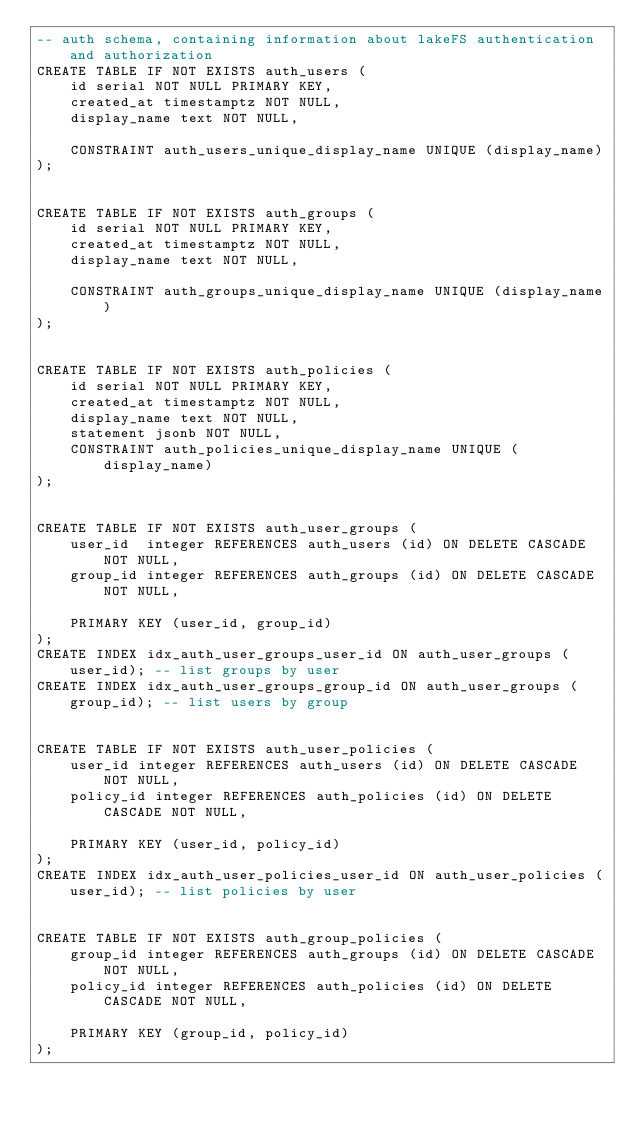Convert code to text. <code><loc_0><loc_0><loc_500><loc_500><_SQL_>-- auth schema, containing information about lakeFS authentication and authorization
CREATE TABLE IF NOT EXISTS auth_users (
    id serial NOT NULL PRIMARY KEY,
    created_at timestamptz NOT NULL,
    display_name text NOT NULL,

    CONSTRAINT auth_users_unique_display_name UNIQUE (display_name)
);


CREATE TABLE IF NOT EXISTS auth_groups (
    id serial NOT NULL PRIMARY KEY,
    created_at timestamptz NOT NULL,
    display_name text NOT NULL,

    CONSTRAINT auth_groups_unique_display_name UNIQUE (display_name)
);


CREATE TABLE IF NOT EXISTS auth_policies (
    id serial NOT NULL PRIMARY KEY,
    created_at timestamptz NOT NULL,
    display_name text NOT NULL,
    statement jsonb NOT NULL,
    CONSTRAINT auth_policies_unique_display_name UNIQUE (display_name)
);


CREATE TABLE IF NOT EXISTS auth_user_groups (
    user_id  integer REFERENCES auth_users (id) ON DELETE CASCADE NOT NULL,
    group_id integer REFERENCES auth_groups (id) ON DELETE CASCADE NOT NULL,

    PRIMARY KEY (user_id, group_id)
);
CREATE INDEX idx_auth_user_groups_user_id ON auth_user_groups (user_id); -- list groups by user
CREATE INDEX idx_auth_user_groups_group_id ON auth_user_groups (group_id); -- list users by group


CREATE TABLE IF NOT EXISTS auth_user_policies (
    user_id integer REFERENCES auth_users (id) ON DELETE CASCADE NOT NULL,
    policy_id integer REFERENCES auth_policies (id) ON DELETE CASCADE NOT NULL,

    PRIMARY KEY (user_id, policy_id)
);
CREATE INDEX idx_auth_user_policies_user_id ON auth_user_policies (user_id); -- list policies by user


CREATE TABLE IF NOT EXISTS auth_group_policies (
    group_id integer REFERENCES auth_groups (id) ON DELETE CASCADE NOT NULL,
    policy_id integer REFERENCES auth_policies (id) ON DELETE CASCADE NOT NULL,

    PRIMARY KEY (group_id, policy_id)
);</code> 